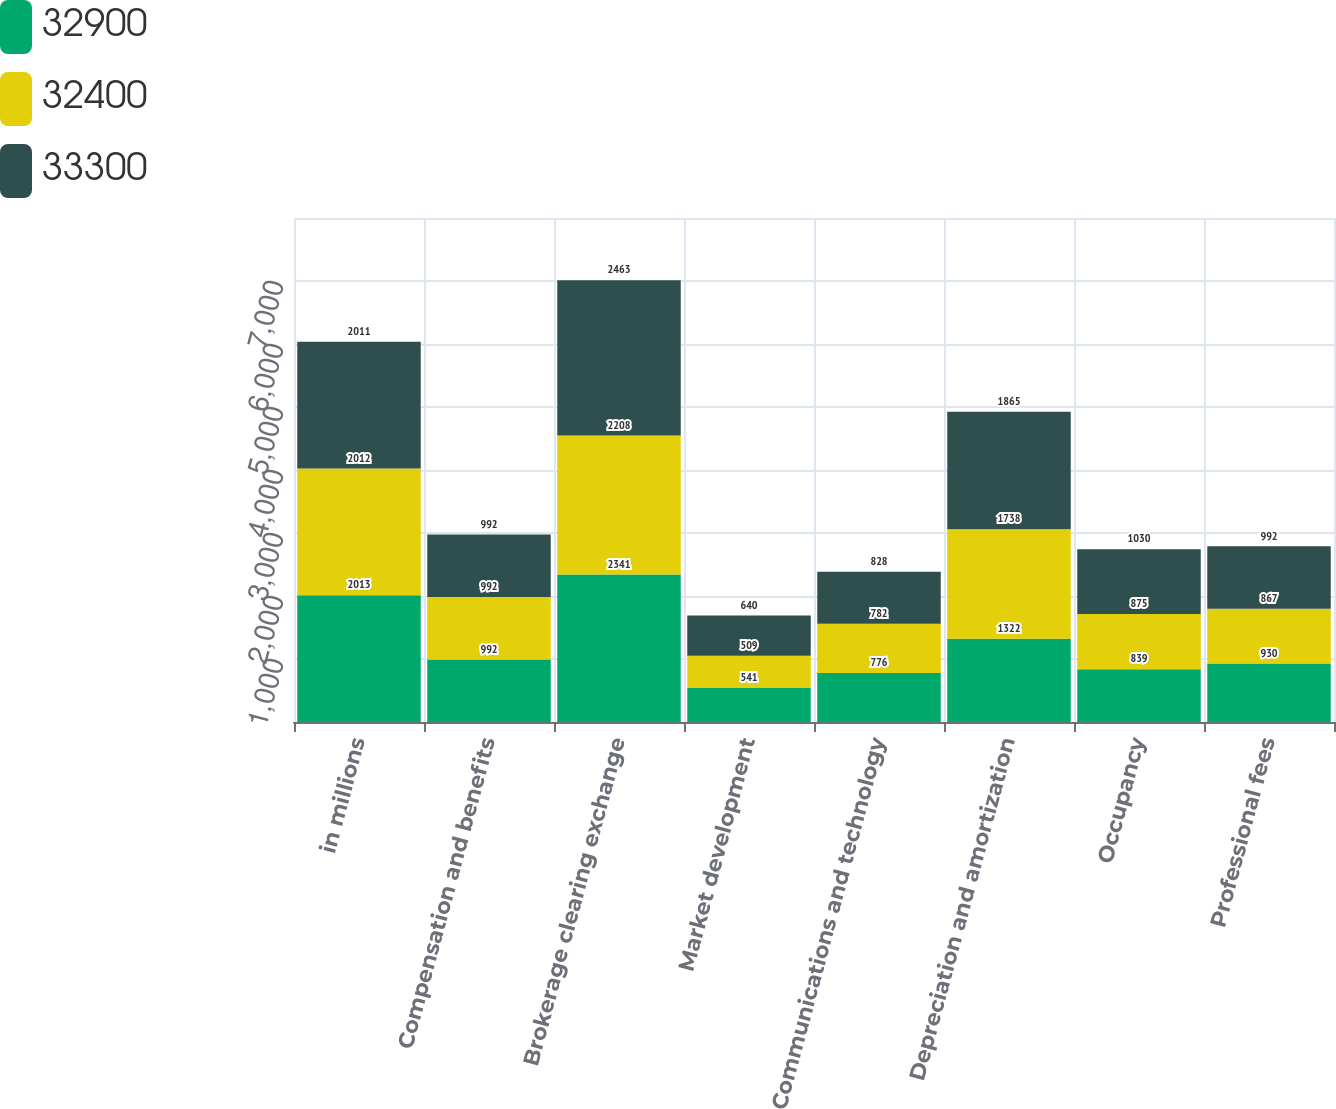Convert chart to OTSL. <chart><loc_0><loc_0><loc_500><loc_500><stacked_bar_chart><ecel><fcel>in millions<fcel>Compensation and benefits<fcel>Brokerage clearing exchange<fcel>Market development<fcel>Communications and technology<fcel>Depreciation and amortization<fcel>Occupancy<fcel>Professional fees<nl><fcel>32900<fcel>2013<fcel>992<fcel>2341<fcel>541<fcel>776<fcel>1322<fcel>839<fcel>930<nl><fcel>32400<fcel>2012<fcel>992<fcel>2208<fcel>509<fcel>782<fcel>1738<fcel>875<fcel>867<nl><fcel>33300<fcel>2011<fcel>992<fcel>2463<fcel>640<fcel>828<fcel>1865<fcel>1030<fcel>992<nl></chart> 